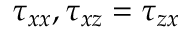Convert formula to latex. <formula><loc_0><loc_0><loc_500><loc_500>\tau _ { x x } , \tau _ { x z } = \tau _ { z x }</formula> 